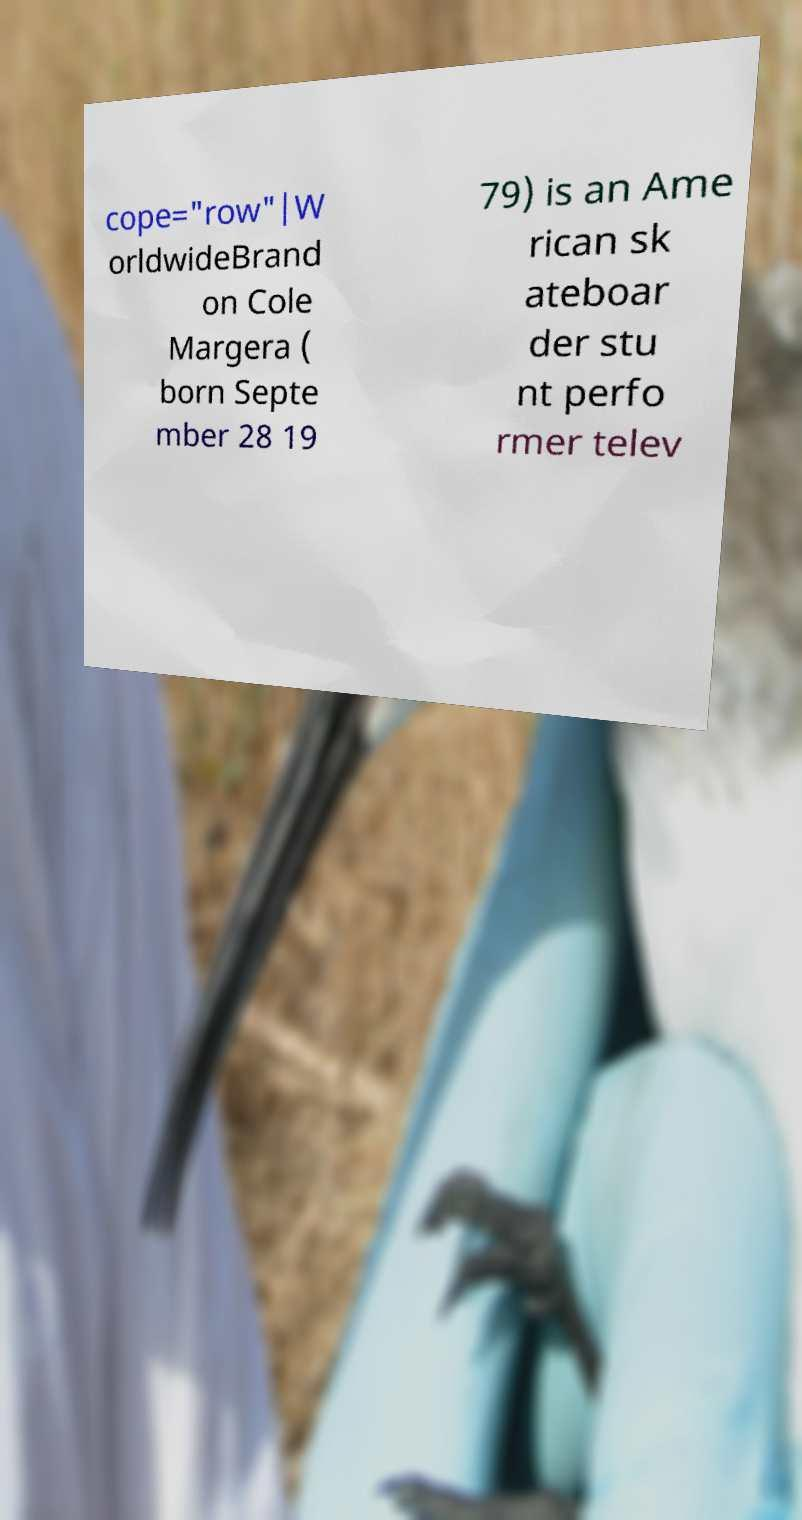Please identify and transcribe the text found in this image. cope="row"|W orldwideBrand on Cole Margera ( born Septe mber 28 19 79) is an Ame rican sk ateboar der stu nt perfo rmer telev 